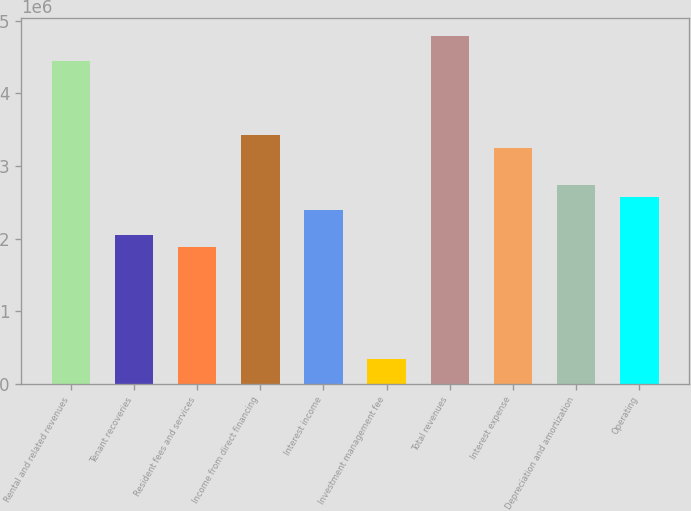Convert chart. <chart><loc_0><loc_0><loc_500><loc_500><bar_chart><fcel>Rental and related revenues<fcel>Tenant recoveries<fcel>Resident fees and services<fcel>Income from direct financing<fcel>Interest income<fcel>Investment management fee<fcel>Total revenues<fcel>Interest expense<fcel>Depreciation and amortization<fcel>Operating<nl><fcel>4.45145e+06<fcel>2.05452e+06<fcel>1.88331e+06<fcel>3.42419e+06<fcel>2.39693e+06<fcel>342419<fcel>4.79387e+06<fcel>3.25298e+06<fcel>2.73935e+06<fcel>2.56814e+06<nl></chart> 